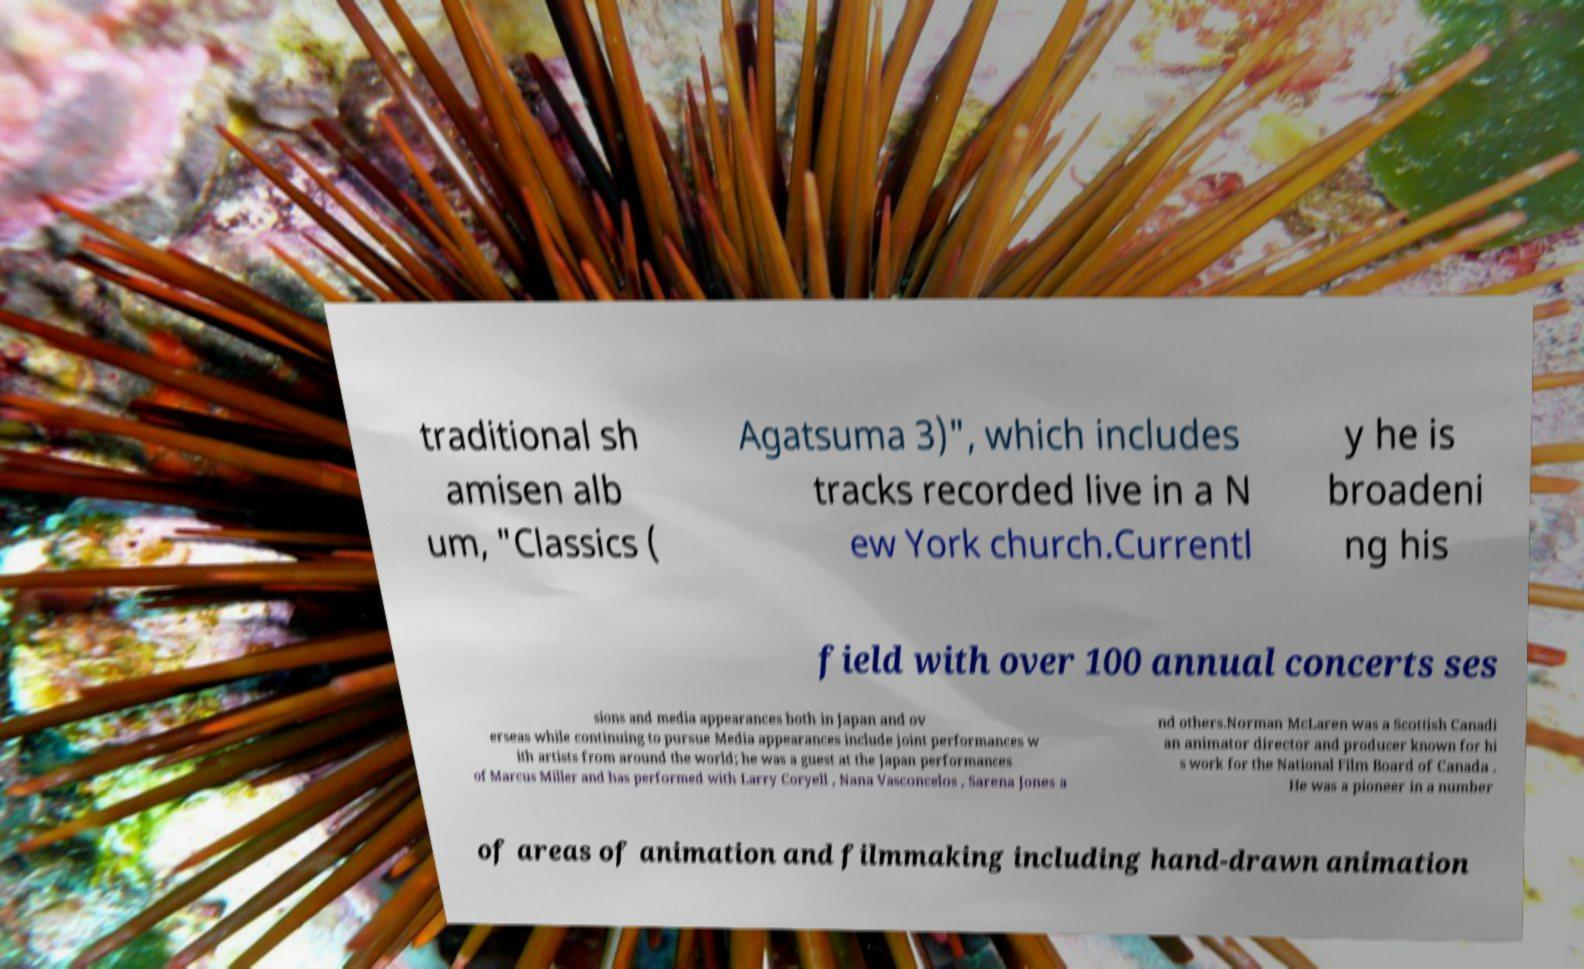Can you accurately transcribe the text from the provided image for me? traditional sh amisen alb um, "Classics ( Agatsuma 3)", which includes tracks recorded live in a N ew York church.Currentl y he is broadeni ng his field with over 100 annual concerts ses sions and media appearances both in Japan and ov erseas while continuing to pursue Media appearances include joint performances w ith artists from around the world; he was a guest at the Japan performances of Marcus Miller and has performed with Larry Coryell , Nana Vasconcelos , Sarena Jones a nd others.Norman McLaren was a Scottish Canadi an animator director and producer known for hi s work for the National Film Board of Canada . He was a pioneer in a number of areas of animation and filmmaking including hand-drawn animation 